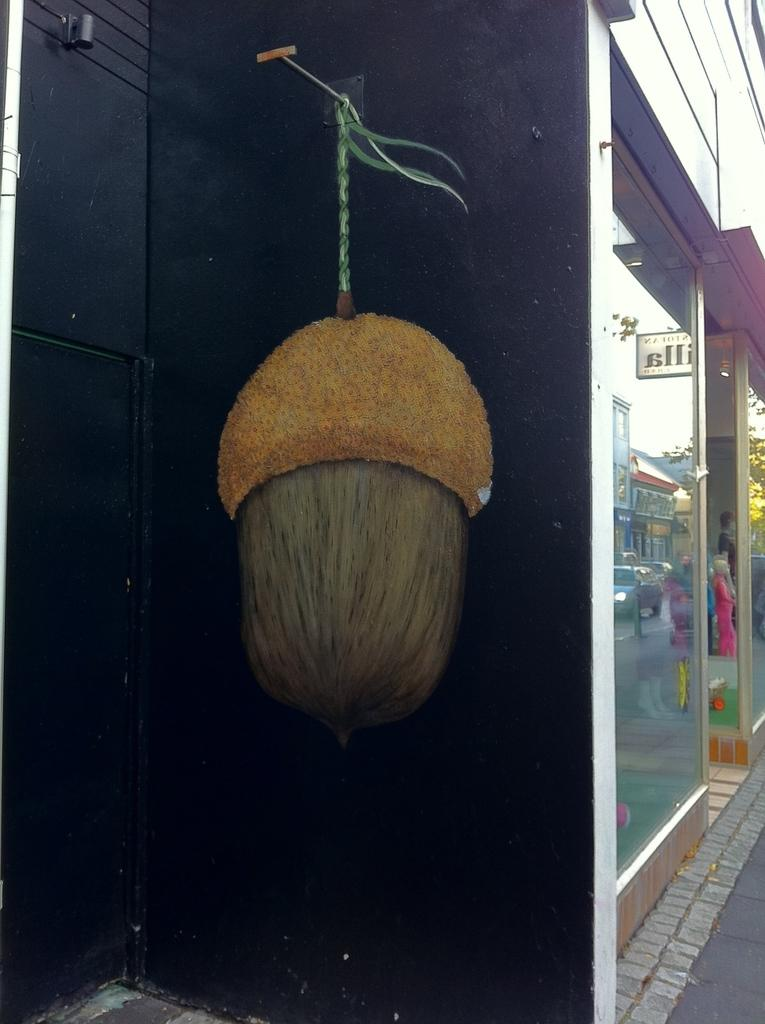What is present on the wall in the image? There is a wall painting on the wall in the image. What type of establishment is depicted in the image? There is a store in the image. Can you describe the wall painting in more detail? Unfortunately, the provided facts do not offer more detail about the wall painting. What is the purpose of the protest happening outside the store in the image? There is no protest present in the image; it only features a wall painting and a store. Who gave their approval for the wall painting in the image? The provided facts do not offer information about who approved the wall painting or if approval was needed. 